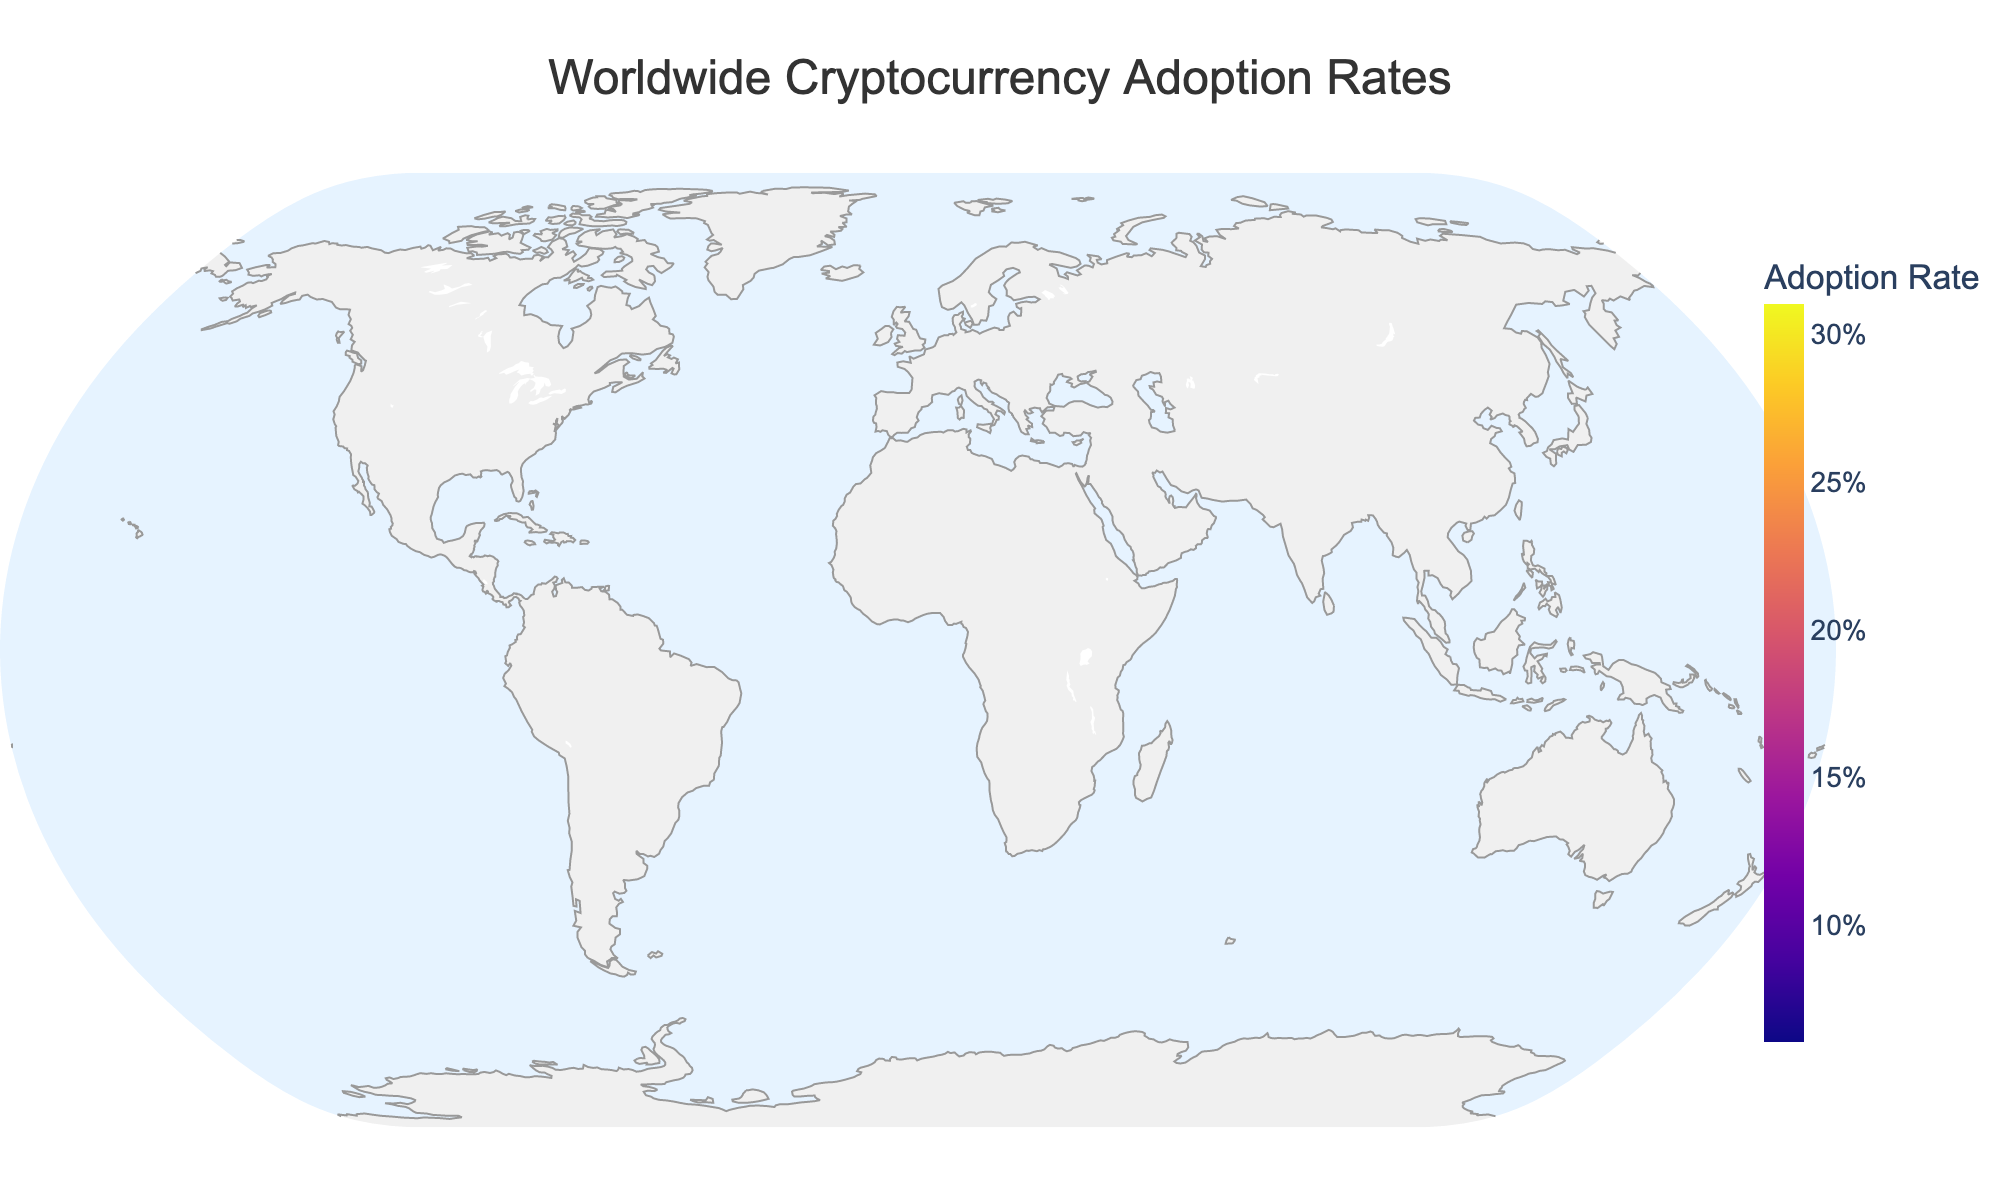What is the title of the figure? The title of a plot is usually placed at the top and often summarizes the main topic or data being shown. In this plot, the title clearly states what the data is about.
Answer: "Worldwide Cryptocurrency Adoption Rates" Which region has the highest cryptocurrency adoption rate? Look at the region with the darkest color on the plot, which indicates the highest adoption rate. Cross-reference this with the color bar to confirm the region.
Answer: East Asia Which two regions have the lowest cryptocurrency adoption rates? Look at the regions with the lightest colors on the map, which represent the lowest adoption rates. Cross-reference these regions with the color bar to identify the values.
Answer: Central Asia and Africa What are the cryptocurrency adoption rates for North America and Western Europe? Look at the colors of North America and Western Europe and match these colors to the values indicated on the color bar.
Answer: North America: 0.23, Western Europe: 0.18 How does the cryptocurrency adoption rate in South Asia compare to Latin America? Find the colors for South Asia and Latin America on the map and compare them to the color bar to see their respective values. Then compare these values directly.
Answer: South Asia has a slightly higher adoption rate (0.15) than Latin America (0.14) What is the total cryptocurrency adoption rate if you sum the rates for regions in Asia (East Asia, Southeast Asia, South Asia, and Central Asia)? First identify each region's rate from the map. Sum the adoption rates: 0.31 (East Asia) + 0.27 (Southeast Asia) + 0.15 (South Asia) + 0.06 (Central Asia).
Answer: 0.79 Calculate the average cryptocurrency adoption rate for the regions shown. Sum all the adoption rates from the regions and divide by the total number of regions (12). The calculation is (0.23 + 0.18 + 0.12 + 0.31 + 0.27 + 0.15 + 0.09 + 0.07 + 0.14 + 0.11 + 0.06 + 0.08) / 12.
Answer: 0.1467 Which region has an adoption rate closest to the average cryptocurrency adoption rate? First, calculate the average rate. Then find the region whose rate is numerically closest to this average by comparing all regions' rates to 0.1467.
Answer: South Asia (0.15) What is the difference in adoption rates between the region with the highest rate and the region with the lowest rate? Identify the highest rate (East Asia, 0.31) and the lowest rate (Central Asia, 0.06). Subtract the lowest from the highest: 0.31 - 0.06.
Answer: 0.25 What is the range of adoption rates shown in the figure? Identify the highest and lowest values among the adoption rates. The range is the difference between these two values: 0.31 (East Asia) - 0.06 (Central Asia).
Answer: 0.25 